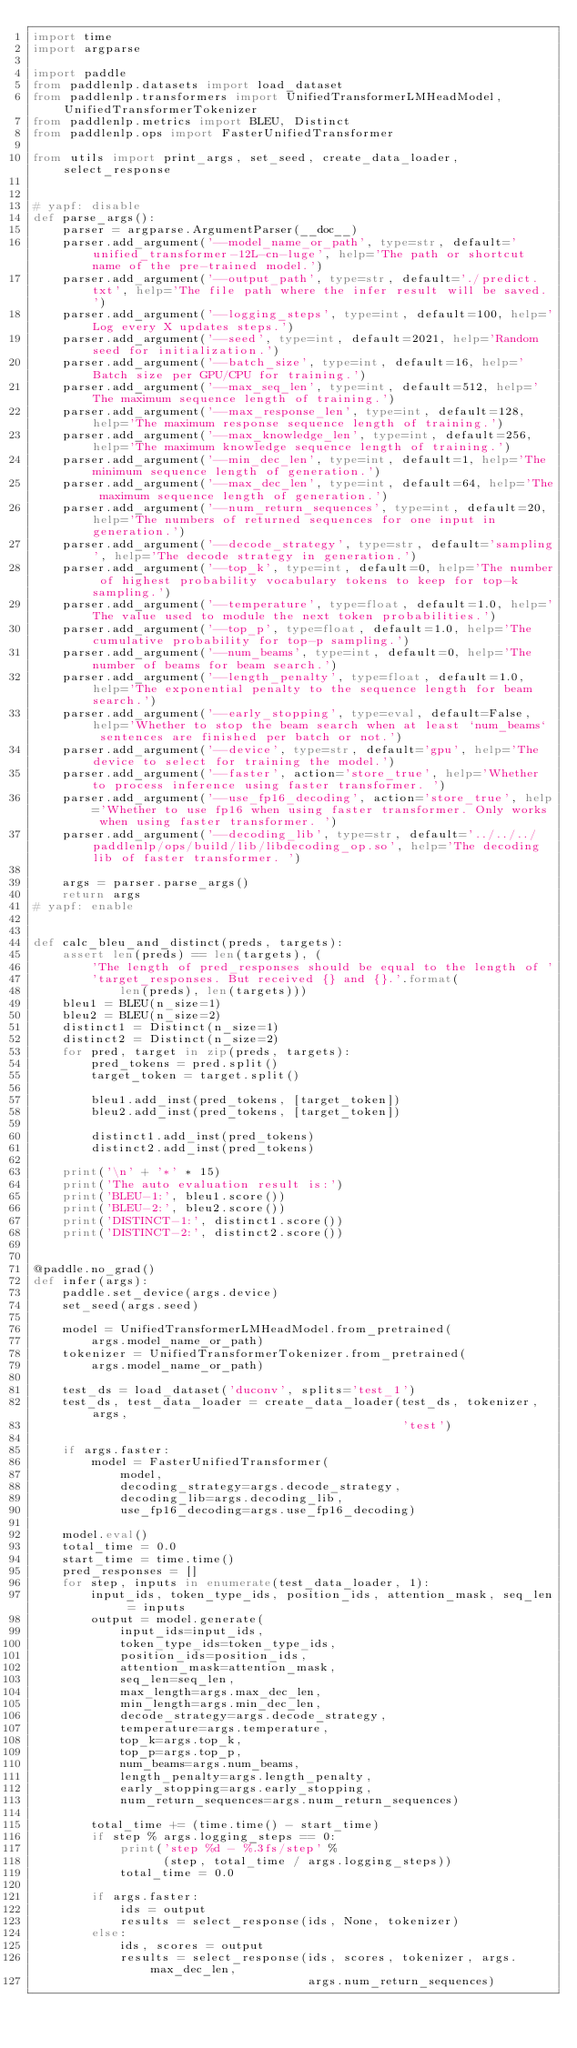<code> <loc_0><loc_0><loc_500><loc_500><_Python_>import time
import argparse

import paddle
from paddlenlp.datasets import load_dataset
from paddlenlp.transformers import UnifiedTransformerLMHeadModel, UnifiedTransformerTokenizer
from paddlenlp.metrics import BLEU, Distinct
from paddlenlp.ops import FasterUnifiedTransformer

from utils import print_args, set_seed, create_data_loader, select_response


# yapf: disable
def parse_args():
    parser = argparse.ArgumentParser(__doc__)
    parser.add_argument('--model_name_or_path', type=str, default='unified_transformer-12L-cn-luge', help='The path or shortcut name of the pre-trained model.')
    parser.add_argument('--output_path', type=str, default='./predict.txt', help='The file path where the infer result will be saved.')
    parser.add_argument('--logging_steps', type=int, default=100, help='Log every X updates steps.')
    parser.add_argument('--seed', type=int, default=2021, help='Random seed for initialization.')
    parser.add_argument('--batch_size', type=int, default=16, help='Batch size per GPU/CPU for training.')
    parser.add_argument('--max_seq_len', type=int, default=512, help='The maximum sequence length of training.')
    parser.add_argument('--max_response_len', type=int, default=128, help='The maximum response sequence length of training.')
    parser.add_argument('--max_knowledge_len', type=int, default=256, help='The maximum knowledge sequence length of training.')
    parser.add_argument('--min_dec_len', type=int, default=1, help='The minimum sequence length of generation.')
    parser.add_argument('--max_dec_len', type=int, default=64, help='The maximum sequence length of generation.')
    parser.add_argument('--num_return_sequences', type=int, default=20, help='The numbers of returned sequences for one input in generation.')
    parser.add_argument('--decode_strategy', type=str, default='sampling', help='The decode strategy in generation.')
    parser.add_argument('--top_k', type=int, default=0, help='The number of highest probability vocabulary tokens to keep for top-k sampling.')
    parser.add_argument('--temperature', type=float, default=1.0, help='The value used to module the next token probabilities.')
    parser.add_argument('--top_p', type=float, default=1.0, help='The cumulative probability for top-p sampling.')
    parser.add_argument('--num_beams', type=int, default=0, help='The number of beams for beam search.')
    parser.add_argument('--length_penalty', type=float, default=1.0, help='The exponential penalty to the sequence length for beam search.')
    parser.add_argument('--early_stopping', type=eval, default=False, help='Whether to stop the beam search when at least `num_beams` sentences are finished per batch or not.')
    parser.add_argument('--device', type=str, default='gpu', help='The device to select for training the model.')
    parser.add_argument('--faster', action='store_true', help='Whether to process inference using faster transformer. ')
    parser.add_argument('--use_fp16_decoding', action='store_true', help='Whether to use fp16 when using faster transformer. Only works when using faster transformer. ')
    parser.add_argument('--decoding_lib', type=str, default='../../../paddlenlp/ops/build/lib/libdecoding_op.so', help='The decoding lib of faster transformer. ')

    args = parser.parse_args()
    return args
# yapf: enable


def calc_bleu_and_distinct(preds, targets):
    assert len(preds) == len(targets), (
        'The length of pred_responses should be equal to the length of '
        'target_responses. But received {} and {}.'.format(
            len(preds), len(targets)))
    bleu1 = BLEU(n_size=1)
    bleu2 = BLEU(n_size=2)
    distinct1 = Distinct(n_size=1)
    distinct2 = Distinct(n_size=2)
    for pred, target in zip(preds, targets):
        pred_tokens = pred.split()
        target_token = target.split()

        bleu1.add_inst(pred_tokens, [target_token])
        bleu2.add_inst(pred_tokens, [target_token])

        distinct1.add_inst(pred_tokens)
        distinct2.add_inst(pred_tokens)

    print('\n' + '*' * 15)
    print('The auto evaluation result is:')
    print('BLEU-1:', bleu1.score())
    print('BLEU-2:', bleu2.score())
    print('DISTINCT-1:', distinct1.score())
    print('DISTINCT-2:', distinct2.score())


@paddle.no_grad()
def infer(args):
    paddle.set_device(args.device)
    set_seed(args.seed)

    model = UnifiedTransformerLMHeadModel.from_pretrained(
        args.model_name_or_path)
    tokenizer = UnifiedTransformerTokenizer.from_pretrained(
        args.model_name_or_path)

    test_ds = load_dataset('duconv', splits='test_1')
    test_ds, test_data_loader = create_data_loader(test_ds, tokenizer, args,
                                                   'test')

    if args.faster:
        model = FasterUnifiedTransformer(
            model,
            decoding_strategy=args.decode_strategy,
            decoding_lib=args.decoding_lib,
            use_fp16_decoding=args.use_fp16_decoding)

    model.eval()
    total_time = 0.0
    start_time = time.time()
    pred_responses = []
    for step, inputs in enumerate(test_data_loader, 1):
        input_ids, token_type_ids, position_ids, attention_mask, seq_len = inputs
        output = model.generate(
            input_ids=input_ids,
            token_type_ids=token_type_ids,
            position_ids=position_ids,
            attention_mask=attention_mask,
            seq_len=seq_len,
            max_length=args.max_dec_len,
            min_length=args.min_dec_len,
            decode_strategy=args.decode_strategy,
            temperature=args.temperature,
            top_k=args.top_k,
            top_p=args.top_p,
            num_beams=args.num_beams,
            length_penalty=args.length_penalty,
            early_stopping=args.early_stopping,
            num_return_sequences=args.num_return_sequences)

        total_time += (time.time() - start_time)
        if step % args.logging_steps == 0:
            print('step %d - %.3fs/step' %
                  (step, total_time / args.logging_steps))
            total_time = 0.0

        if args.faster:
            ids = output
            results = select_response(ids, None, tokenizer)
        else:
            ids, scores = output
            results = select_response(ids, scores, tokenizer, args.max_dec_len,
                                      args.num_return_sequences)</code> 